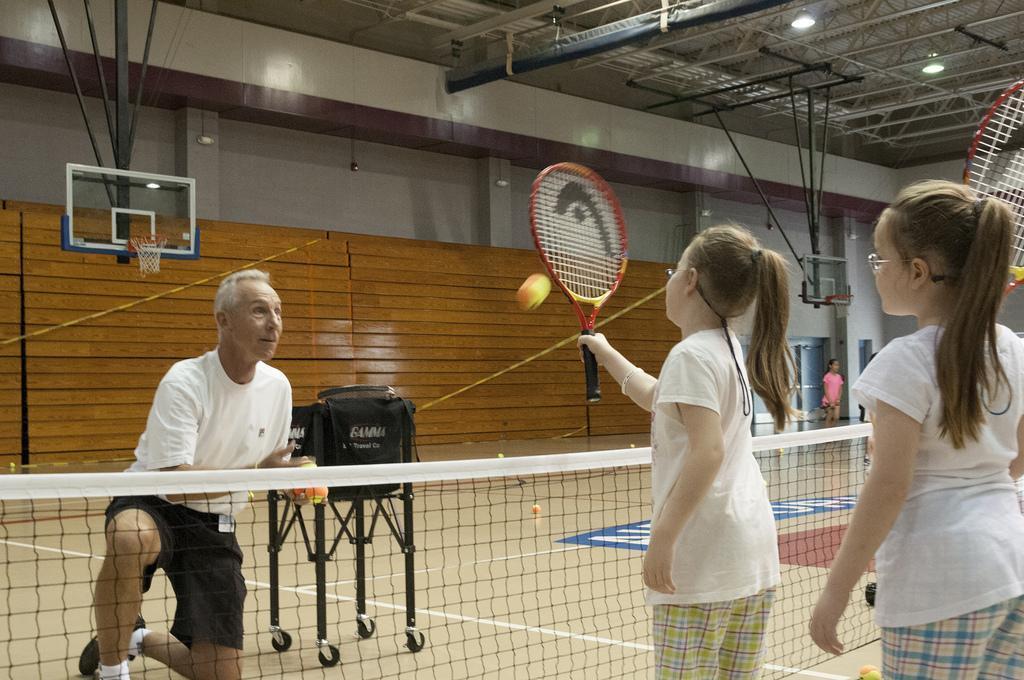How many people wearing glasses?
Give a very brief answer. 2. 